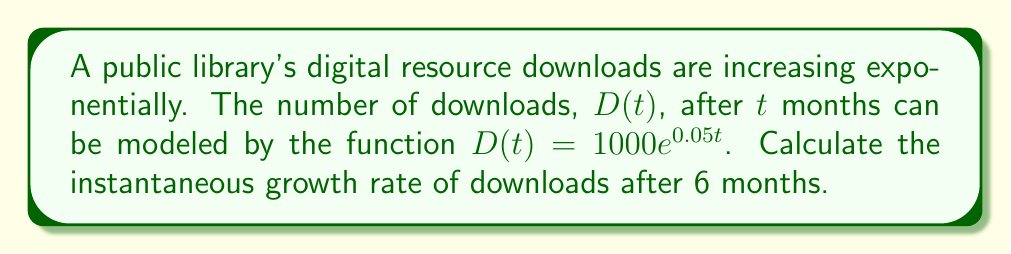Solve this math problem. To find the instantaneous growth rate, we need to calculate the derivative of the function $D(t)$ and evaluate it at $t=6$. Here's the step-by-step process:

1) The given function is $D(t) = 1000e^{0.05t}$

2) To find the derivative, we use the chain rule:
   $$\frac{d}{dt}[D(t)] = 1000 \cdot \frac{d}{dt}[e^{0.05t}]$$
   $$\frac{d}{dt}[D(t)] = 1000 \cdot e^{0.05t} \cdot 0.05$$
   $$D'(t) = 50e^{0.05t}$$

3) The instantaneous growth rate at $t=6$ is found by evaluating $D'(6)$:
   $$D'(6) = 50e^{0.05(6)}$$
   $$D'(6) = 50e^{0.3}$$
   $$D'(6) = 50 \cdot 1.34986$$
   $$D'(6) \approx 67.493$$

This means that after 6 months, the number of downloads is increasing at a rate of approximately 67.493 downloads per month.
Answer: $67.493$ downloads per month 